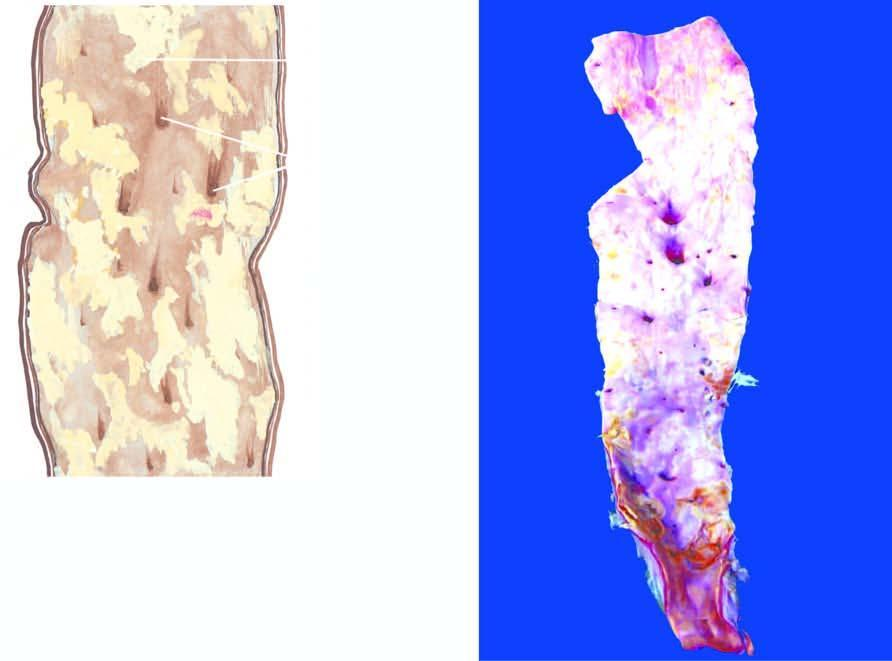what are orifices of some of the branches coming out of the wall narrowed by?
Answer the question using a single word or phrase. The atherosclerotic process 